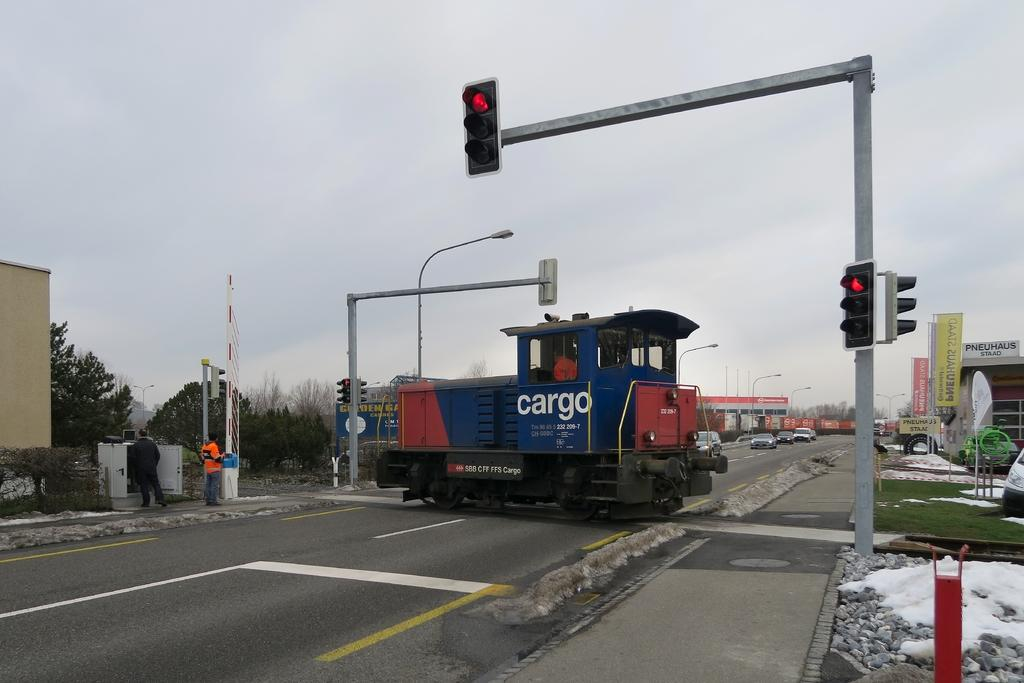<image>
Create a compact narrative representing the image presented. A blue and red train engine says "cargo" on the side in white letters. 